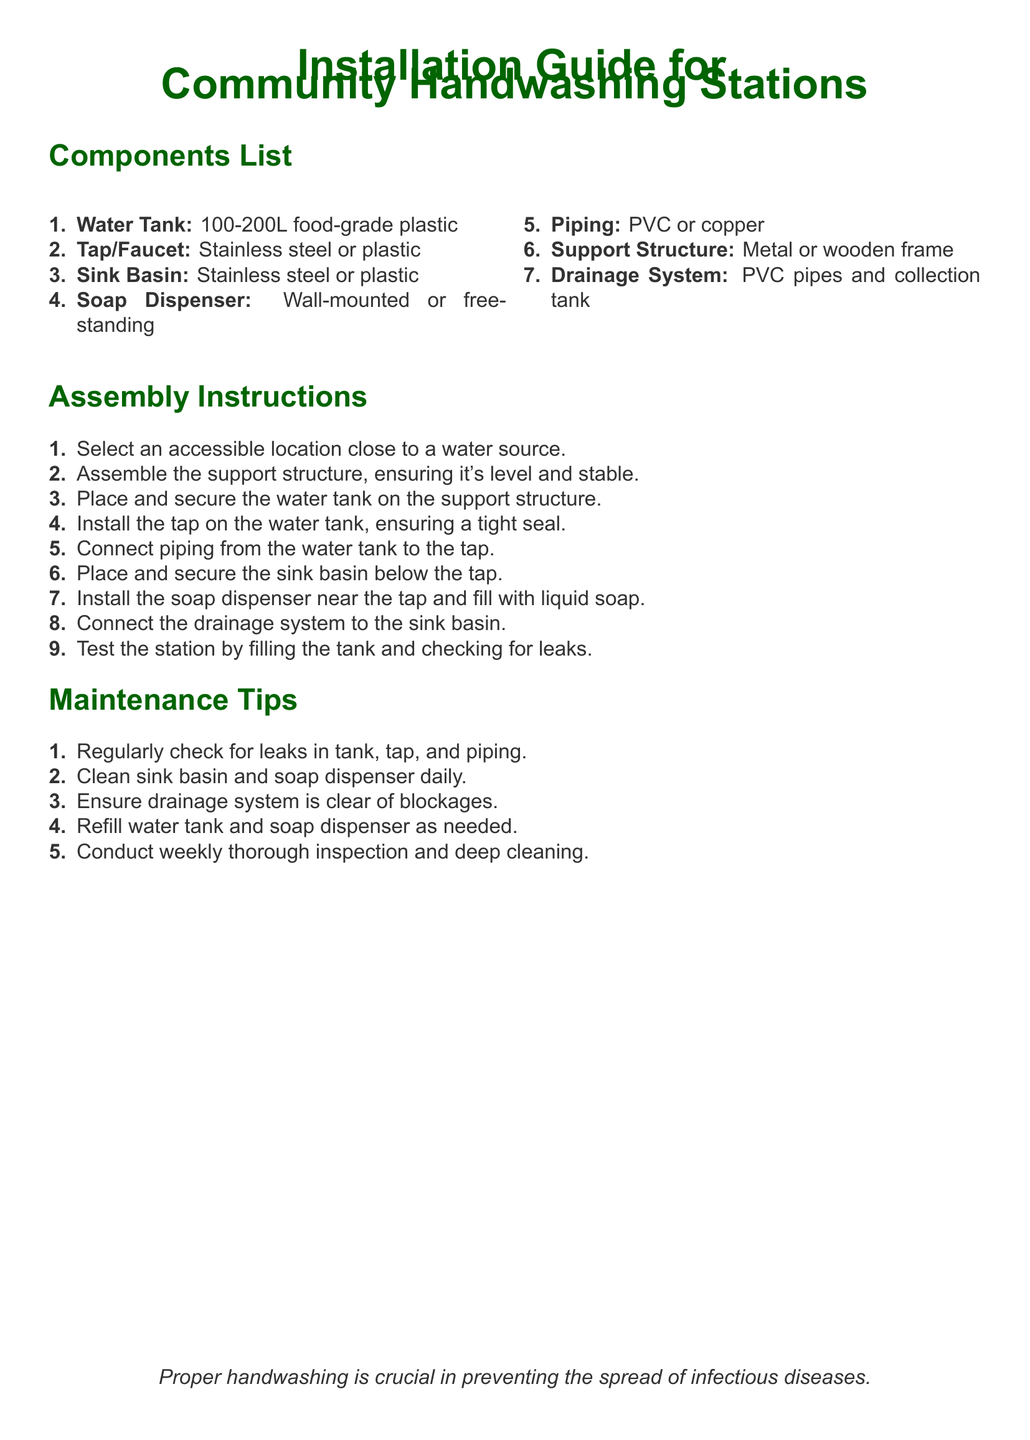What is the capacity of the water tank? The capacity of the water tank is specified as 100-200L in the document.
Answer: 100-200L What material is the sink basin made of? The document lists the sink basin as being made of stainless steel or plastic.
Answer: Stainless steel or plastic How many components are listed in the document? By counting the items in the Components List, there are a total of 7 components listed.
Answer: 7 What is the first step in the assembly instructions? The first step in the assembly instructions is to select an accessible location close to a water source.
Answer: Select an accessible location close to a water source What should you check for in the maintenance tips? The maintenance tips suggest regularly checking for leaks in the tank, tap, and piping.
Answer: Leaks in tank, tap, and piping Where should the soap dispenser be installed? The document states that the soap dispenser should be installed near the tap.
Answer: Near the tap What should you do if the drainage system is blocked? The maintenance tips indicate to ensure the drainage system is clear of blockages.
Answer: Clear of blockages What type of frame can be used for the support structure? The support structure can be made of metal or wooden frame, as mentioned in the document.
Answer: Metal or wooden frame How often should the thorough inspection and deep cleaning be conducted? The document advises conducting a thorough inspection and deep cleaning weekly.
Answer: Weekly 